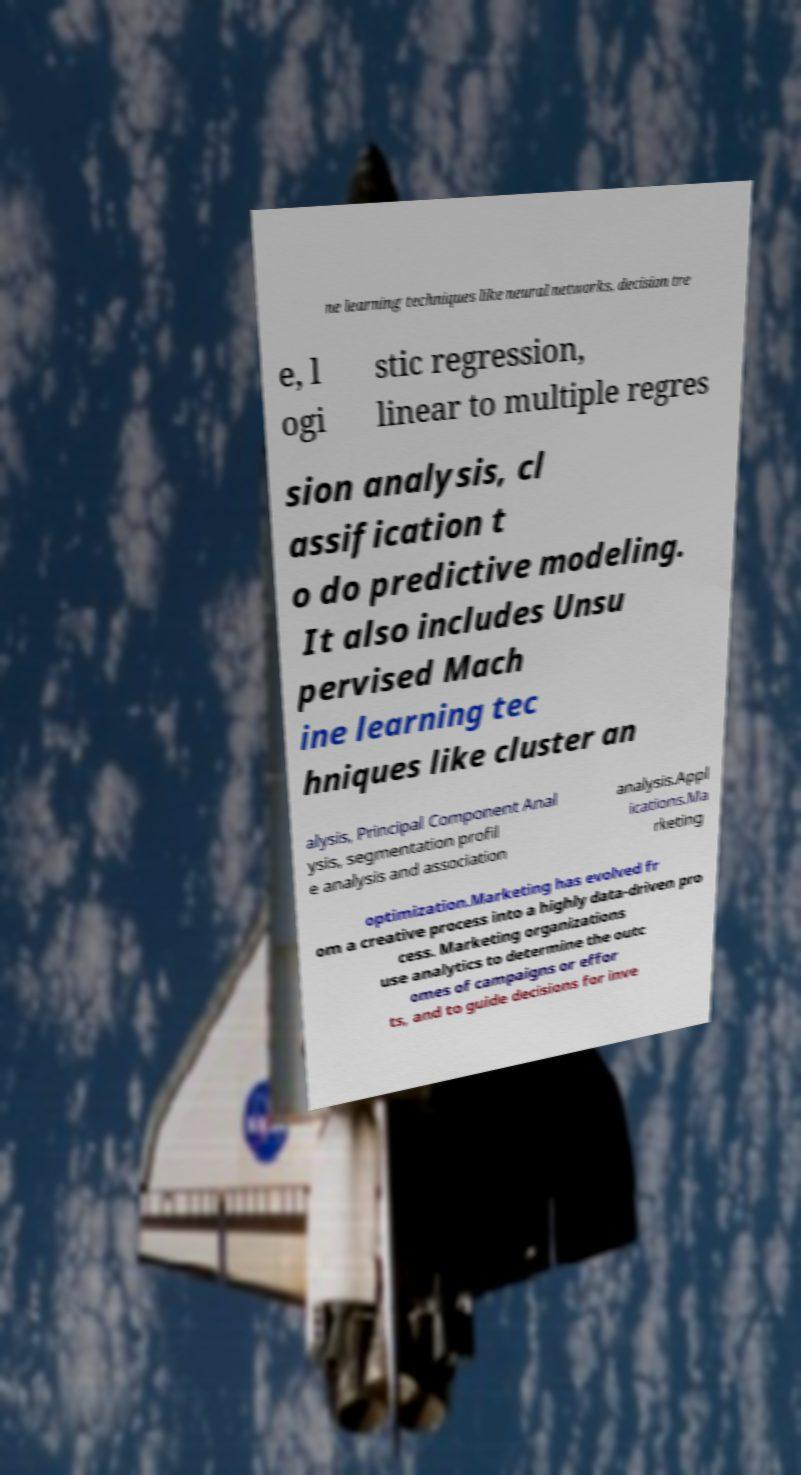Can you read and provide the text displayed in the image?This photo seems to have some interesting text. Can you extract and type it out for me? ne learning techniques like neural networks, decision tre e, l ogi stic regression, linear to multiple regres sion analysis, cl assification t o do predictive modeling. It also includes Unsu pervised Mach ine learning tec hniques like cluster an alysis, Principal Component Anal ysis, segmentation profil e analysis and association analysis.Appl ications.Ma rketing optimization.Marketing has evolved fr om a creative process into a highly data-driven pro cess. Marketing organizations use analytics to determine the outc omes of campaigns or effor ts, and to guide decisions for inve 